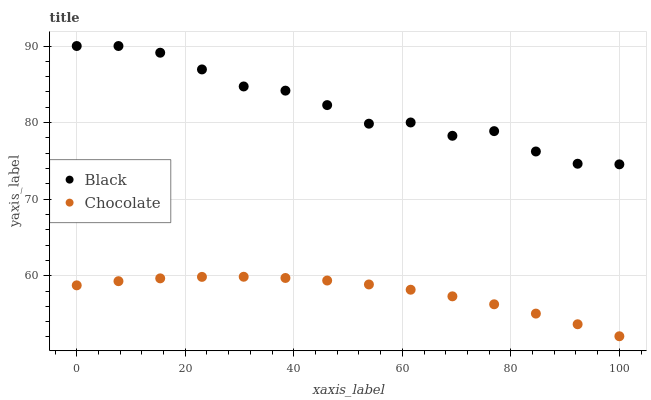Does Chocolate have the minimum area under the curve?
Answer yes or no. Yes. Does Black have the maximum area under the curve?
Answer yes or no. Yes. Does Chocolate have the maximum area under the curve?
Answer yes or no. No. Is Chocolate the smoothest?
Answer yes or no. Yes. Is Black the roughest?
Answer yes or no. Yes. Is Chocolate the roughest?
Answer yes or no. No. Does Chocolate have the lowest value?
Answer yes or no. Yes. Does Black have the highest value?
Answer yes or no. Yes. Does Chocolate have the highest value?
Answer yes or no. No. Is Chocolate less than Black?
Answer yes or no. Yes. Is Black greater than Chocolate?
Answer yes or no. Yes. Does Chocolate intersect Black?
Answer yes or no. No. 